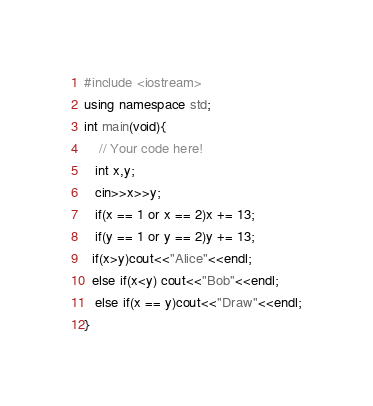Convert code to text. <code><loc_0><loc_0><loc_500><loc_500><_C++_>#include <iostream>
using namespace std;
int main(void){
    // Your code here!
   int x,y;
   cin>>x>>y;
   if(x == 1 or x == 2)x += 13;
   if(y == 1 or y == 2)y += 13;
  if(x>y)cout<<"Alice"<<endl;
  else if(x<y) cout<<"Bob"<<endl;
   else if(x == y)cout<<"Draw"<<endl;
}</code> 